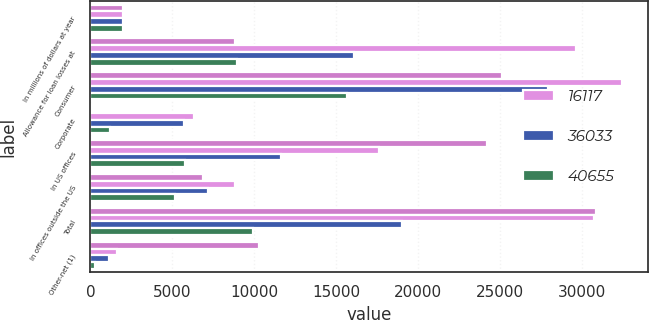Convert chart. <chart><loc_0><loc_0><loc_500><loc_500><stacked_bar_chart><ecel><fcel>In millions of dollars at year<fcel>Allowance for loan losses at<fcel>Consumer<fcel>Corporate<fcel>In US offices<fcel>In offices outside the US<fcel>Total<fcel>Other-net (1)<nl><fcel>nan<fcel>2010<fcel>8834<fcel>25119<fcel>75<fcel>24183<fcel>6892<fcel>30859<fcel>10287<nl><fcel>16117<fcel>2009<fcel>29616<fcel>32418<fcel>6342<fcel>17637<fcel>8834<fcel>30741<fcel>1602<nl><fcel>36033<fcel>2008<fcel>16117<fcel>27942<fcel>5732<fcel>11624<fcel>7172<fcel>19011<fcel>1164<nl><fcel>40655<fcel>2007<fcel>8940<fcel>15660<fcel>1172<fcel>5765<fcel>5165<fcel>9926<fcel>271<nl></chart> 